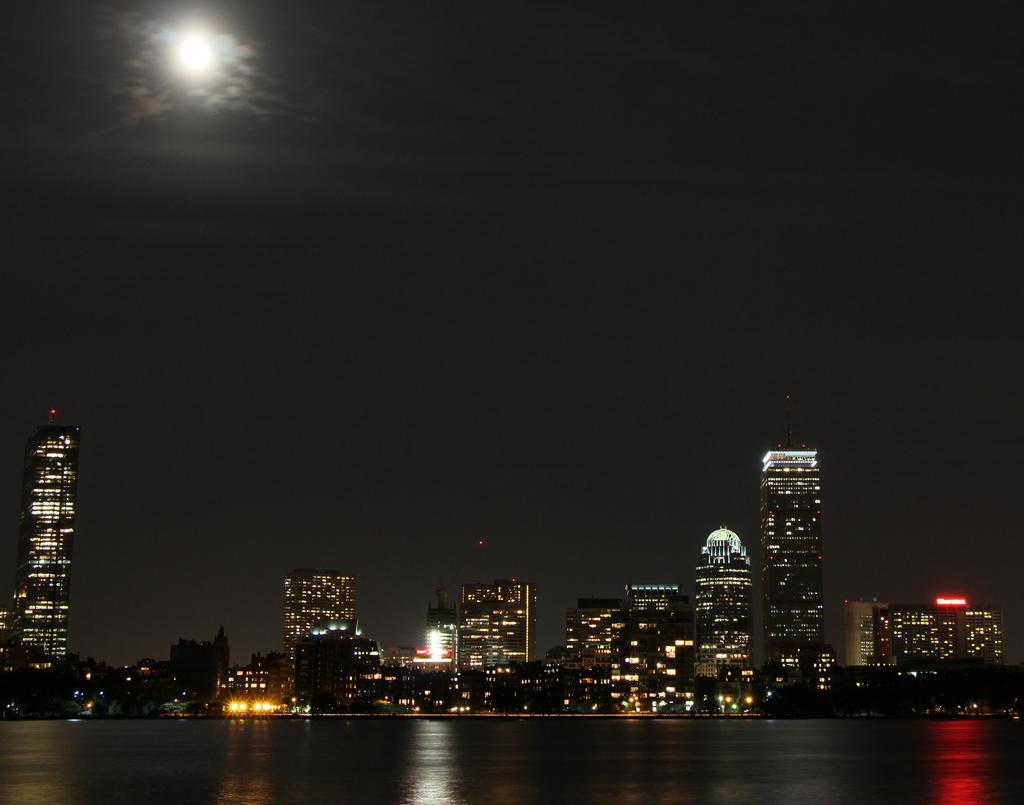What type of structures can be seen in the image? There are buildings in the image. What can be seen illuminated in the image? There are lights visible in the image. What natural element is present in the image? There is water visible in the image. What celestial body is present in the image? The moon is present in the image. How would you describe the overall lighting in the image? The image appears to be dark. Can you tell me how many frogs are sitting on the buildings in the image? There are no frogs present in the image; it features buildings, lights, water, and the moon. What type of pain is being experienced by the finger in the image? There is no finger or any indication of pain present in the image. 